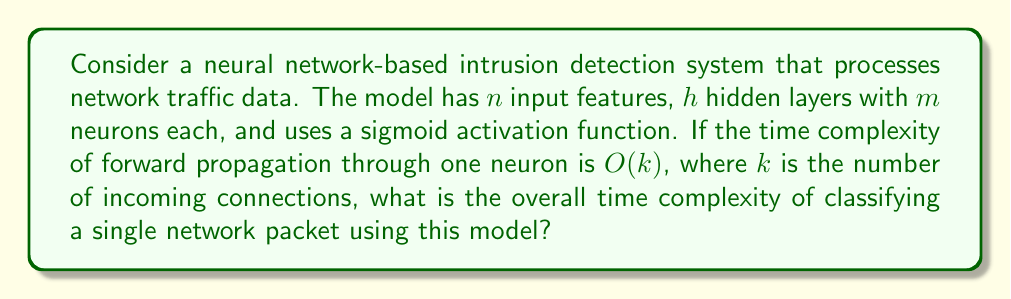Teach me how to tackle this problem. Let's break this down step-by-step:

1) Input layer: There are $n$ input features, so the first hidden layer will have $n$ incoming connections to each of its neurons.

2) Hidden layers: There are $h$ hidden layers, each with $m$ neurons. Each neuron in a hidden layer (except the first) has $m$ incoming connections from the previous layer.

3) Output layer: Assuming a binary classification (intrusion or not), there is one output neuron with $m$ incoming connections from the last hidden layer.

4) Time complexity for each layer:
   - First hidden layer: $O(mnk)$ (m neurons, each with n inputs)
   - Subsequent hidden layers: $O(m^2k)$ each (m neurons, each with m inputs)
   - Output layer: $O(mk)$ (1 neuron with m inputs)

5) Total time complexity:
   $$O(mnk + (h-1)m^2k + mk)$$

6) Simplifying:
   $$O(mnk + hm^2k)$$

7) Since $h$ and $m$ are constants defined by the model architecture, and $k$ is a constant representing the time complexity of processing one neuron, we can further simplify:

   $$O(n + m^2)$$

This represents the dominant terms as the input size $n$ grows or as the model becomes more complex (larger $m$).
Answer: $O(n + m^2)$ 